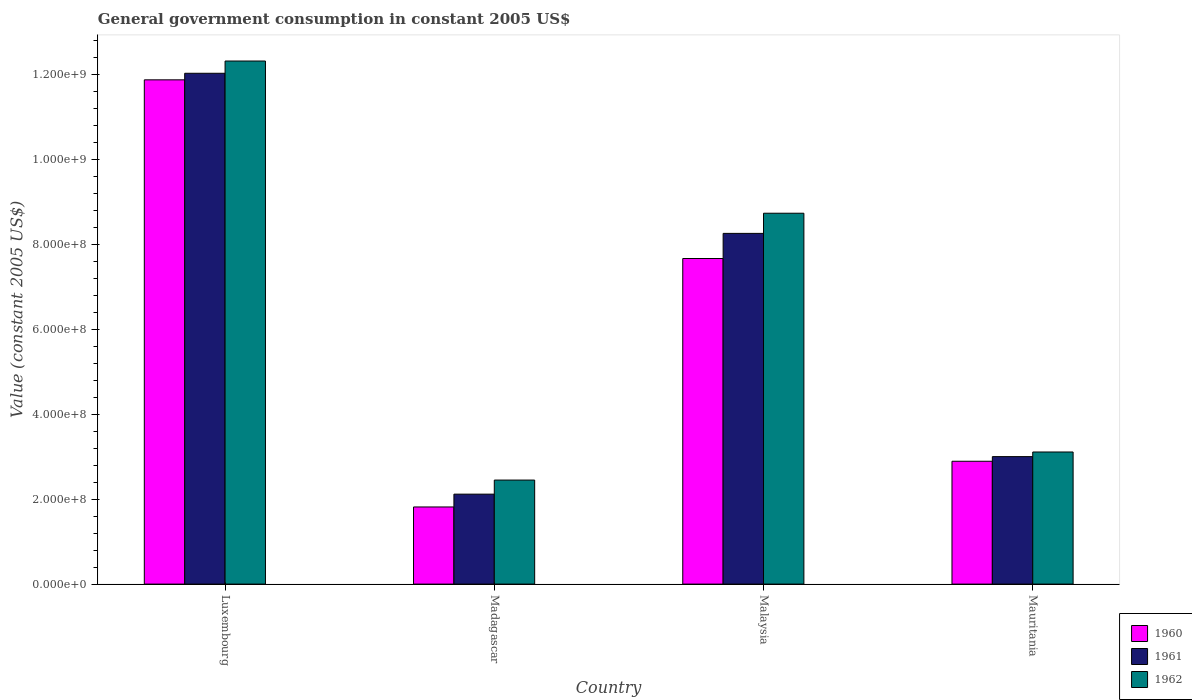How many different coloured bars are there?
Offer a terse response. 3. What is the label of the 2nd group of bars from the left?
Provide a succinct answer. Madagascar. What is the government conusmption in 1960 in Madagascar?
Your response must be concise. 1.82e+08. Across all countries, what is the maximum government conusmption in 1962?
Ensure brevity in your answer.  1.23e+09. Across all countries, what is the minimum government conusmption in 1961?
Ensure brevity in your answer.  2.12e+08. In which country was the government conusmption in 1962 maximum?
Your response must be concise. Luxembourg. In which country was the government conusmption in 1961 minimum?
Your answer should be compact. Madagascar. What is the total government conusmption in 1961 in the graph?
Provide a succinct answer. 2.54e+09. What is the difference between the government conusmption in 1962 in Malaysia and that in Mauritania?
Provide a short and direct response. 5.63e+08. What is the difference between the government conusmption in 1961 in Mauritania and the government conusmption in 1962 in Luxembourg?
Give a very brief answer. -9.32e+08. What is the average government conusmption in 1960 per country?
Ensure brevity in your answer.  6.07e+08. What is the difference between the government conusmption of/in 1962 and government conusmption of/in 1961 in Malaysia?
Offer a terse response. 4.75e+07. What is the ratio of the government conusmption in 1962 in Madagascar to that in Mauritania?
Your response must be concise. 0.79. Is the government conusmption in 1962 in Madagascar less than that in Malaysia?
Give a very brief answer. Yes. Is the difference between the government conusmption in 1962 in Luxembourg and Mauritania greater than the difference between the government conusmption in 1961 in Luxembourg and Mauritania?
Offer a terse response. Yes. What is the difference between the highest and the second highest government conusmption in 1960?
Ensure brevity in your answer.  8.99e+08. What is the difference between the highest and the lowest government conusmption in 1962?
Give a very brief answer. 9.87e+08. What does the 2nd bar from the left in Mauritania represents?
Provide a short and direct response. 1961. What does the 1st bar from the right in Malaysia represents?
Your answer should be compact. 1962. Are the values on the major ticks of Y-axis written in scientific E-notation?
Offer a terse response. Yes. Does the graph contain any zero values?
Offer a terse response. No. Where does the legend appear in the graph?
Ensure brevity in your answer.  Bottom right. How many legend labels are there?
Your answer should be compact. 3. How are the legend labels stacked?
Make the answer very short. Vertical. What is the title of the graph?
Make the answer very short. General government consumption in constant 2005 US$. What is the label or title of the Y-axis?
Provide a short and direct response. Value (constant 2005 US$). What is the Value (constant 2005 US$) in 1960 in Luxembourg?
Keep it short and to the point. 1.19e+09. What is the Value (constant 2005 US$) in 1961 in Luxembourg?
Your answer should be compact. 1.20e+09. What is the Value (constant 2005 US$) in 1962 in Luxembourg?
Make the answer very short. 1.23e+09. What is the Value (constant 2005 US$) of 1960 in Madagascar?
Your answer should be very brief. 1.82e+08. What is the Value (constant 2005 US$) of 1961 in Madagascar?
Make the answer very short. 2.12e+08. What is the Value (constant 2005 US$) of 1962 in Madagascar?
Your response must be concise. 2.45e+08. What is the Value (constant 2005 US$) in 1960 in Malaysia?
Give a very brief answer. 7.67e+08. What is the Value (constant 2005 US$) of 1961 in Malaysia?
Your answer should be compact. 8.26e+08. What is the Value (constant 2005 US$) of 1962 in Malaysia?
Provide a short and direct response. 8.74e+08. What is the Value (constant 2005 US$) in 1960 in Mauritania?
Offer a terse response. 2.89e+08. What is the Value (constant 2005 US$) in 1961 in Mauritania?
Offer a terse response. 3.00e+08. What is the Value (constant 2005 US$) in 1962 in Mauritania?
Keep it short and to the point. 3.11e+08. Across all countries, what is the maximum Value (constant 2005 US$) in 1960?
Offer a very short reply. 1.19e+09. Across all countries, what is the maximum Value (constant 2005 US$) of 1961?
Keep it short and to the point. 1.20e+09. Across all countries, what is the maximum Value (constant 2005 US$) in 1962?
Your response must be concise. 1.23e+09. Across all countries, what is the minimum Value (constant 2005 US$) of 1960?
Give a very brief answer. 1.82e+08. Across all countries, what is the minimum Value (constant 2005 US$) in 1961?
Ensure brevity in your answer.  2.12e+08. Across all countries, what is the minimum Value (constant 2005 US$) in 1962?
Provide a short and direct response. 2.45e+08. What is the total Value (constant 2005 US$) in 1960 in the graph?
Keep it short and to the point. 2.43e+09. What is the total Value (constant 2005 US$) of 1961 in the graph?
Your answer should be very brief. 2.54e+09. What is the total Value (constant 2005 US$) in 1962 in the graph?
Your response must be concise. 2.66e+09. What is the difference between the Value (constant 2005 US$) of 1960 in Luxembourg and that in Madagascar?
Give a very brief answer. 1.01e+09. What is the difference between the Value (constant 2005 US$) in 1961 in Luxembourg and that in Madagascar?
Your answer should be very brief. 9.92e+08. What is the difference between the Value (constant 2005 US$) in 1962 in Luxembourg and that in Madagascar?
Make the answer very short. 9.87e+08. What is the difference between the Value (constant 2005 US$) of 1960 in Luxembourg and that in Malaysia?
Keep it short and to the point. 4.21e+08. What is the difference between the Value (constant 2005 US$) of 1961 in Luxembourg and that in Malaysia?
Offer a very short reply. 3.77e+08. What is the difference between the Value (constant 2005 US$) in 1962 in Luxembourg and that in Malaysia?
Your answer should be very brief. 3.59e+08. What is the difference between the Value (constant 2005 US$) in 1960 in Luxembourg and that in Mauritania?
Provide a succinct answer. 8.99e+08. What is the difference between the Value (constant 2005 US$) of 1961 in Luxembourg and that in Mauritania?
Provide a short and direct response. 9.03e+08. What is the difference between the Value (constant 2005 US$) in 1962 in Luxembourg and that in Mauritania?
Provide a short and direct response. 9.21e+08. What is the difference between the Value (constant 2005 US$) of 1960 in Madagascar and that in Malaysia?
Offer a very short reply. -5.85e+08. What is the difference between the Value (constant 2005 US$) of 1961 in Madagascar and that in Malaysia?
Make the answer very short. -6.14e+08. What is the difference between the Value (constant 2005 US$) of 1962 in Madagascar and that in Malaysia?
Ensure brevity in your answer.  -6.29e+08. What is the difference between the Value (constant 2005 US$) in 1960 in Madagascar and that in Mauritania?
Offer a very short reply. -1.08e+08. What is the difference between the Value (constant 2005 US$) in 1961 in Madagascar and that in Mauritania?
Ensure brevity in your answer.  -8.84e+07. What is the difference between the Value (constant 2005 US$) in 1962 in Madagascar and that in Mauritania?
Offer a very short reply. -6.62e+07. What is the difference between the Value (constant 2005 US$) of 1960 in Malaysia and that in Mauritania?
Offer a terse response. 4.78e+08. What is the difference between the Value (constant 2005 US$) in 1961 in Malaysia and that in Mauritania?
Your answer should be compact. 5.26e+08. What is the difference between the Value (constant 2005 US$) in 1962 in Malaysia and that in Mauritania?
Provide a succinct answer. 5.63e+08. What is the difference between the Value (constant 2005 US$) in 1960 in Luxembourg and the Value (constant 2005 US$) in 1961 in Madagascar?
Provide a succinct answer. 9.76e+08. What is the difference between the Value (constant 2005 US$) in 1960 in Luxembourg and the Value (constant 2005 US$) in 1962 in Madagascar?
Offer a terse response. 9.43e+08. What is the difference between the Value (constant 2005 US$) of 1961 in Luxembourg and the Value (constant 2005 US$) of 1962 in Madagascar?
Keep it short and to the point. 9.59e+08. What is the difference between the Value (constant 2005 US$) in 1960 in Luxembourg and the Value (constant 2005 US$) in 1961 in Malaysia?
Your answer should be very brief. 3.62e+08. What is the difference between the Value (constant 2005 US$) in 1960 in Luxembourg and the Value (constant 2005 US$) in 1962 in Malaysia?
Your answer should be compact. 3.14e+08. What is the difference between the Value (constant 2005 US$) in 1961 in Luxembourg and the Value (constant 2005 US$) in 1962 in Malaysia?
Your answer should be very brief. 3.30e+08. What is the difference between the Value (constant 2005 US$) in 1960 in Luxembourg and the Value (constant 2005 US$) in 1961 in Mauritania?
Keep it short and to the point. 8.88e+08. What is the difference between the Value (constant 2005 US$) of 1960 in Luxembourg and the Value (constant 2005 US$) of 1962 in Mauritania?
Your answer should be very brief. 8.77e+08. What is the difference between the Value (constant 2005 US$) of 1961 in Luxembourg and the Value (constant 2005 US$) of 1962 in Mauritania?
Provide a short and direct response. 8.92e+08. What is the difference between the Value (constant 2005 US$) in 1960 in Madagascar and the Value (constant 2005 US$) in 1961 in Malaysia?
Provide a short and direct response. -6.45e+08. What is the difference between the Value (constant 2005 US$) of 1960 in Madagascar and the Value (constant 2005 US$) of 1962 in Malaysia?
Keep it short and to the point. -6.92e+08. What is the difference between the Value (constant 2005 US$) in 1961 in Madagascar and the Value (constant 2005 US$) in 1962 in Malaysia?
Give a very brief answer. -6.62e+08. What is the difference between the Value (constant 2005 US$) of 1960 in Madagascar and the Value (constant 2005 US$) of 1961 in Mauritania?
Keep it short and to the point. -1.19e+08. What is the difference between the Value (constant 2005 US$) in 1960 in Madagascar and the Value (constant 2005 US$) in 1962 in Mauritania?
Make the answer very short. -1.30e+08. What is the difference between the Value (constant 2005 US$) of 1961 in Madagascar and the Value (constant 2005 US$) of 1962 in Mauritania?
Keep it short and to the point. -9.93e+07. What is the difference between the Value (constant 2005 US$) in 1960 in Malaysia and the Value (constant 2005 US$) in 1961 in Mauritania?
Give a very brief answer. 4.67e+08. What is the difference between the Value (constant 2005 US$) in 1960 in Malaysia and the Value (constant 2005 US$) in 1962 in Mauritania?
Provide a succinct answer. 4.56e+08. What is the difference between the Value (constant 2005 US$) in 1961 in Malaysia and the Value (constant 2005 US$) in 1962 in Mauritania?
Give a very brief answer. 5.15e+08. What is the average Value (constant 2005 US$) in 1960 per country?
Make the answer very short. 6.07e+08. What is the average Value (constant 2005 US$) of 1961 per country?
Offer a terse response. 6.36e+08. What is the average Value (constant 2005 US$) in 1962 per country?
Provide a succinct answer. 6.66e+08. What is the difference between the Value (constant 2005 US$) of 1960 and Value (constant 2005 US$) of 1961 in Luxembourg?
Provide a succinct answer. -1.55e+07. What is the difference between the Value (constant 2005 US$) in 1960 and Value (constant 2005 US$) in 1962 in Luxembourg?
Keep it short and to the point. -4.43e+07. What is the difference between the Value (constant 2005 US$) of 1961 and Value (constant 2005 US$) of 1962 in Luxembourg?
Your answer should be very brief. -2.88e+07. What is the difference between the Value (constant 2005 US$) of 1960 and Value (constant 2005 US$) of 1961 in Madagascar?
Ensure brevity in your answer.  -3.02e+07. What is the difference between the Value (constant 2005 US$) of 1960 and Value (constant 2005 US$) of 1962 in Madagascar?
Offer a very short reply. -6.34e+07. What is the difference between the Value (constant 2005 US$) in 1961 and Value (constant 2005 US$) in 1962 in Madagascar?
Give a very brief answer. -3.32e+07. What is the difference between the Value (constant 2005 US$) of 1960 and Value (constant 2005 US$) of 1961 in Malaysia?
Your response must be concise. -5.92e+07. What is the difference between the Value (constant 2005 US$) in 1960 and Value (constant 2005 US$) in 1962 in Malaysia?
Keep it short and to the point. -1.07e+08. What is the difference between the Value (constant 2005 US$) of 1961 and Value (constant 2005 US$) of 1962 in Malaysia?
Make the answer very short. -4.75e+07. What is the difference between the Value (constant 2005 US$) of 1960 and Value (constant 2005 US$) of 1961 in Mauritania?
Make the answer very short. -1.09e+07. What is the difference between the Value (constant 2005 US$) of 1960 and Value (constant 2005 US$) of 1962 in Mauritania?
Make the answer very short. -2.18e+07. What is the difference between the Value (constant 2005 US$) in 1961 and Value (constant 2005 US$) in 1962 in Mauritania?
Keep it short and to the point. -1.09e+07. What is the ratio of the Value (constant 2005 US$) in 1960 in Luxembourg to that in Madagascar?
Your response must be concise. 6.54. What is the ratio of the Value (constant 2005 US$) in 1961 in Luxembourg to that in Madagascar?
Give a very brief answer. 5.68. What is the ratio of the Value (constant 2005 US$) of 1962 in Luxembourg to that in Madagascar?
Ensure brevity in your answer.  5.03. What is the ratio of the Value (constant 2005 US$) in 1960 in Luxembourg to that in Malaysia?
Ensure brevity in your answer.  1.55. What is the ratio of the Value (constant 2005 US$) of 1961 in Luxembourg to that in Malaysia?
Your answer should be compact. 1.46. What is the ratio of the Value (constant 2005 US$) of 1962 in Luxembourg to that in Malaysia?
Your response must be concise. 1.41. What is the ratio of the Value (constant 2005 US$) in 1960 in Luxembourg to that in Mauritania?
Your response must be concise. 4.11. What is the ratio of the Value (constant 2005 US$) in 1961 in Luxembourg to that in Mauritania?
Make the answer very short. 4.01. What is the ratio of the Value (constant 2005 US$) in 1962 in Luxembourg to that in Mauritania?
Make the answer very short. 3.96. What is the ratio of the Value (constant 2005 US$) in 1960 in Madagascar to that in Malaysia?
Keep it short and to the point. 0.24. What is the ratio of the Value (constant 2005 US$) of 1961 in Madagascar to that in Malaysia?
Provide a succinct answer. 0.26. What is the ratio of the Value (constant 2005 US$) in 1962 in Madagascar to that in Malaysia?
Your response must be concise. 0.28. What is the ratio of the Value (constant 2005 US$) of 1960 in Madagascar to that in Mauritania?
Provide a short and direct response. 0.63. What is the ratio of the Value (constant 2005 US$) in 1961 in Madagascar to that in Mauritania?
Offer a very short reply. 0.71. What is the ratio of the Value (constant 2005 US$) of 1962 in Madagascar to that in Mauritania?
Give a very brief answer. 0.79. What is the ratio of the Value (constant 2005 US$) of 1960 in Malaysia to that in Mauritania?
Your answer should be very brief. 2.65. What is the ratio of the Value (constant 2005 US$) in 1961 in Malaysia to that in Mauritania?
Offer a terse response. 2.75. What is the ratio of the Value (constant 2005 US$) of 1962 in Malaysia to that in Mauritania?
Keep it short and to the point. 2.81. What is the difference between the highest and the second highest Value (constant 2005 US$) in 1960?
Your response must be concise. 4.21e+08. What is the difference between the highest and the second highest Value (constant 2005 US$) of 1961?
Your answer should be compact. 3.77e+08. What is the difference between the highest and the second highest Value (constant 2005 US$) of 1962?
Make the answer very short. 3.59e+08. What is the difference between the highest and the lowest Value (constant 2005 US$) in 1960?
Provide a succinct answer. 1.01e+09. What is the difference between the highest and the lowest Value (constant 2005 US$) of 1961?
Provide a short and direct response. 9.92e+08. What is the difference between the highest and the lowest Value (constant 2005 US$) in 1962?
Your answer should be compact. 9.87e+08. 